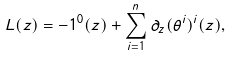<formula> <loc_0><loc_0><loc_500><loc_500>L ( z ) = - 1 ^ { 0 } ( z ) + \sum _ { i = 1 } ^ { n } \partial _ { z } ( \theta ^ { i } ) ^ { i } ( z ) ,</formula> 